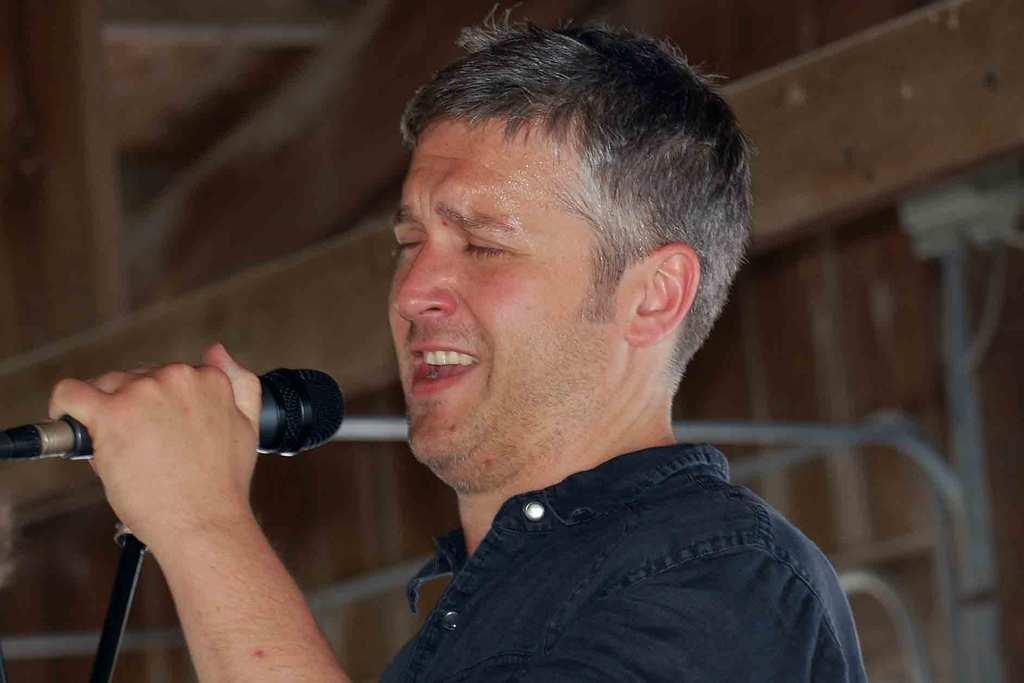What is the main subject of the image? The main subject of the image is a man. What is the man holding in the image? The man is holding a microphone. What is the man doing in the image? The man is singing. Where is the girl in the image? There is no girl present in the image. What type of bread is being smashed in the image? There is no bread or smashing activity present in the image. 